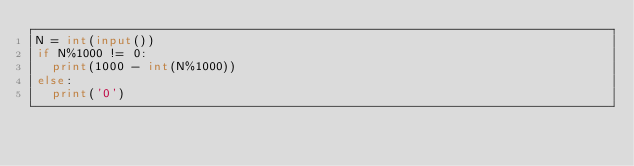Convert code to text. <code><loc_0><loc_0><loc_500><loc_500><_Python_>N = int(input())
if N%1000 != 0:
  print(1000 - int(N%1000))
else:
  print('0')</code> 